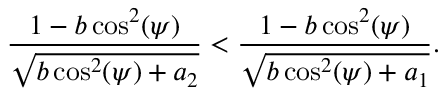<formula> <loc_0><loc_0><loc_500><loc_500>\frac { 1 - b \cos ^ { 2 } ( \psi ) } { \sqrt { b \cos ^ { 2 } ( \psi ) + a _ { 2 } } } < \frac { 1 - b \cos ^ { 2 } ( \psi ) } { \sqrt { b \cos ^ { 2 } ( \psi ) + a _ { 1 } } } .</formula> 